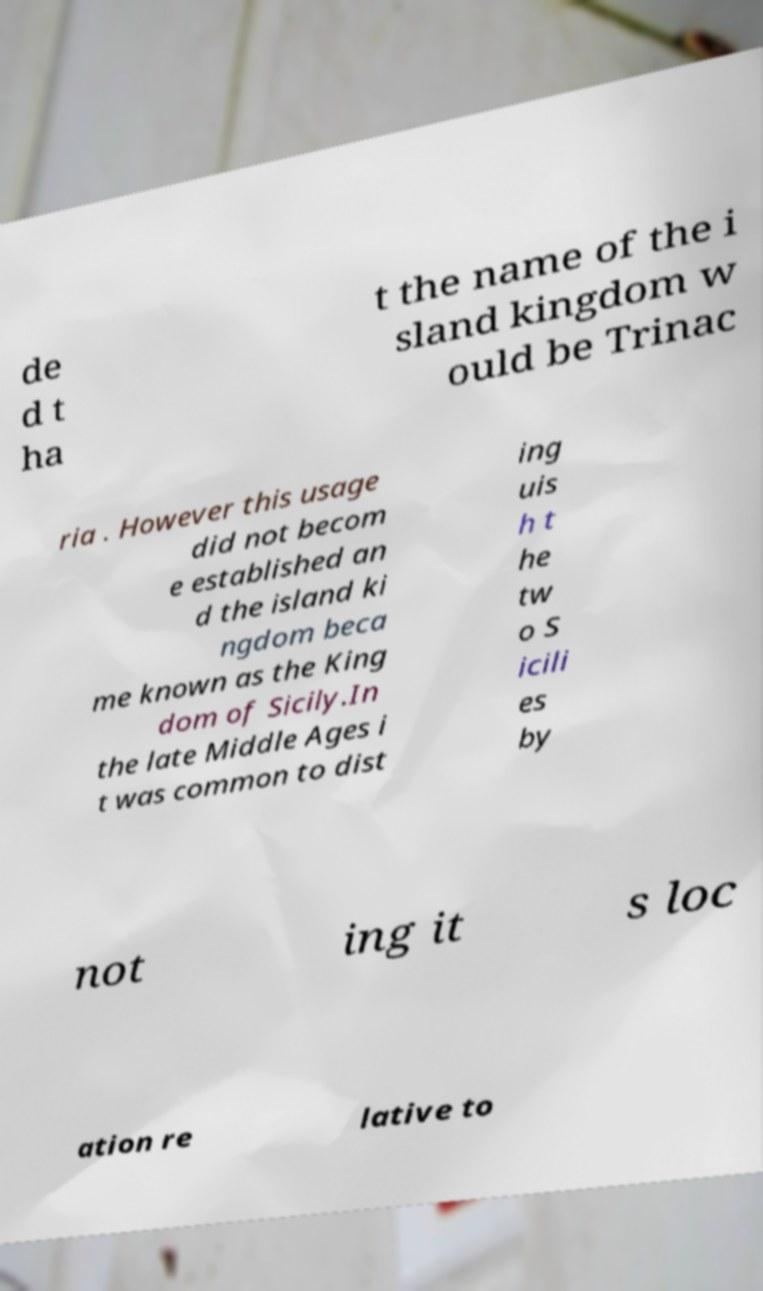Can you read and provide the text displayed in the image?This photo seems to have some interesting text. Can you extract and type it out for me? de d t ha t the name of the i sland kingdom w ould be Trinac ria . However this usage did not becom e established an d the island ki ngdom beca me known as the King dom of Sicily.In the late Middle Ages i t was common to dist ing uis h t he tw o S icili es by not ing it s loc ation re lative to 